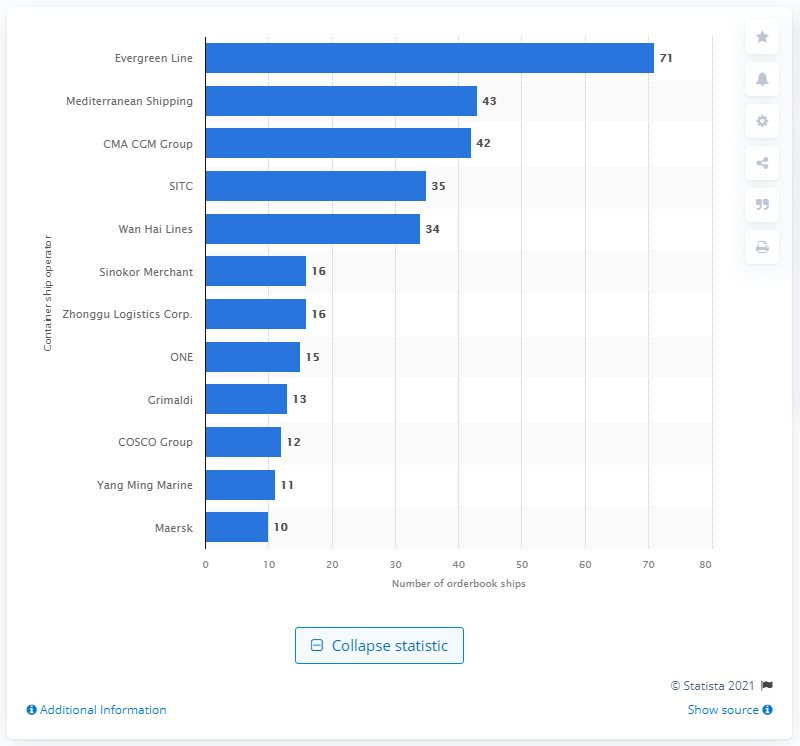Which companies have more than 30 ships in their order books according to the image? According to the image, the companies with more than 30 ships in their order books are Evergreen Line, Mediterranean Shipping with 43 ships, CMA CGM Group with 42 ships, SITC with 35 ships, and Wan Hai Lines with 34 ships. 